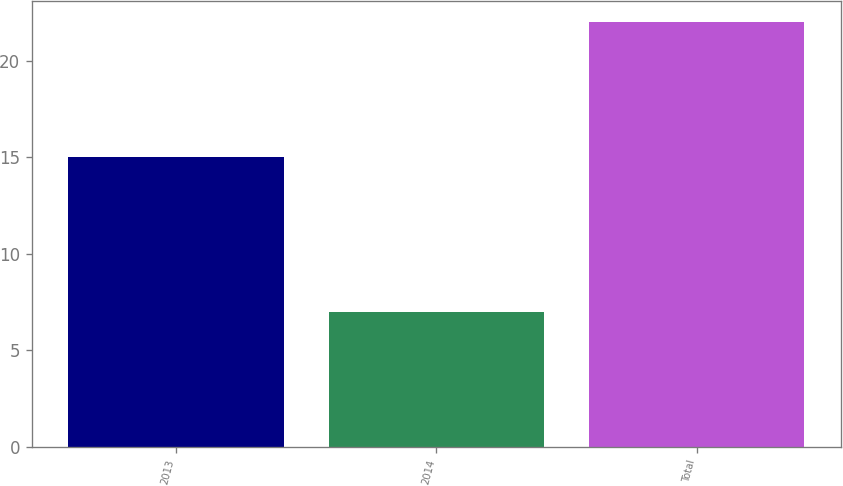<chart> <loc_0><loc_0><loc_500><loc_500><bar_chart><fcel>2013<fcel>2014<fcel>Total<nl><fcel>15<fcel>7<fcel>22<nl></chart> 